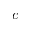Convert formula to latex. <formula><loc_0><loc_0><loc_500><loc_500>c</formula> 